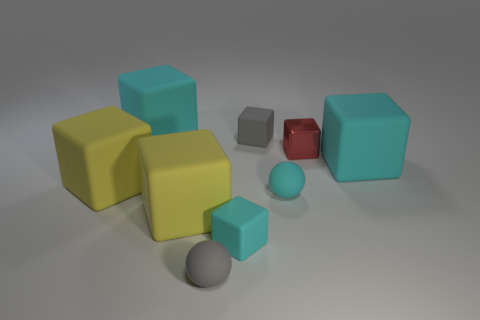There is a small gray object that is the same shape as the red shiny object; what material is it?
Your response must be concise. Rubber. Are the tiny gray sphere and the small cube that is on the right side of the tiny gray cube made of the same material?
Keep it short and to the point. No. What number of objects are large rubber cubes that are left of the shiny object or rubber objects that are on the left side of the gray sphere?
Your answer should be very brief. 3. What number of other things are there of the same color as the metal block?
Your response must be concise. 0. Are there more big blocks that are behind the small red metal block than small gray matte balls in front of the tiny cyan cube?
Ensure brevity in your answer.  No. What number of balls are yellow rubber things or big rubber objects?
Your response must be concise. 0. How many objects are small gray matte things in front of the small red object or tiny red metallic cubes?
Make the answer very short. 2. What is the shape of the gray rubber object that is on the right side of the cyan matte cube in front of the big cyan block in front of the tiny red metal block?
Offer a very short reply. Cube. What number of tiny yellow metal things have the same shape as the red thing?
Keep it short and to the point. 0. Are the gray sphere and the tiny cyan block made of the same material?
Your answer should be compact. Yes. 